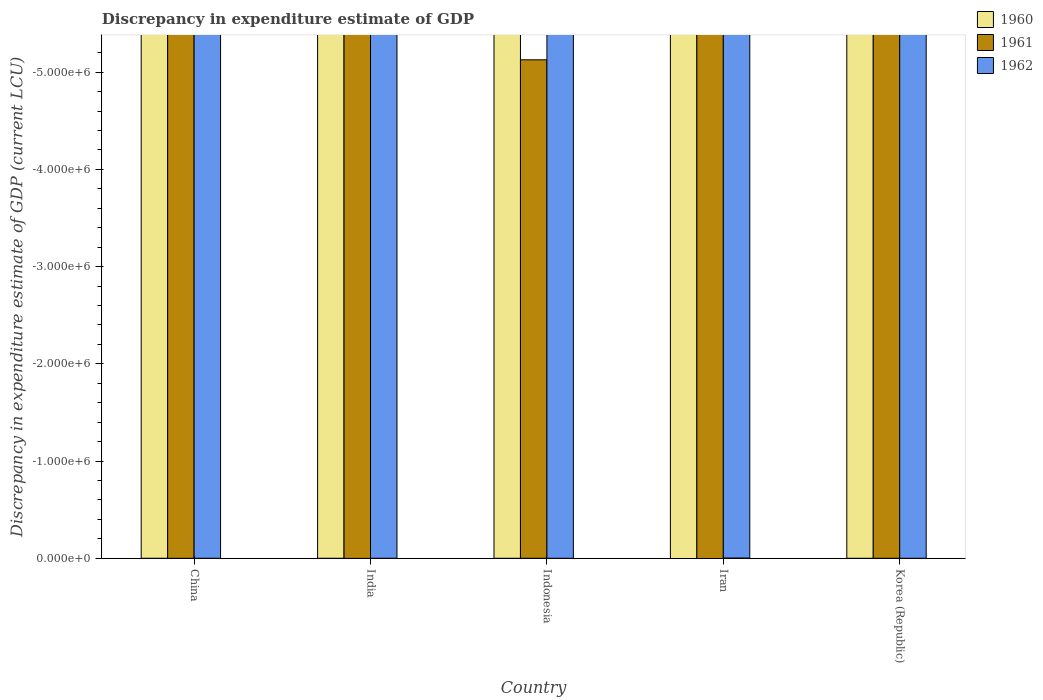How many different coloured bars are there?
Make the answer very short. 0. Are the number of bars per tick equal to the number of legend labels?
Offer a very short reply. No. Are the number of bars on each tick of the X-axis equal?
Your answer should be compact. Yes. How many bars are there on the 1st tick from the left?
Your answer should be compact. 0. What is the label of the 2nd group of bars from the left?
Keep it short and to the point. India. Across all countries, what is the minimum discrepancy in expenditure estimate of GDP in 1960?
Your answer should be compact. 0. What is the total discrepancy in expenditure estimate of GDP in 1962 in the graph?
Ensure brevity in your answer.  0. In how many countries, is the discrepancy in expenditure estimate of GDP in 1962 greater than the average discrepancy in expenditure estimate of GDP in 1962 taken over all countries?
Ensure brevity in your answer.  0. Is it the case that in every country, the sum of the discrepancy in expenditure estimate of GDP in 1962 and discrepancy in expenditure estimate of GDP in 1960 is greater than the discrepancy in expenditure estimate of GDP in 1961?
Keep it short and to the point. No. How many bars are there?
Make the answer very short. 0. Are all the bars in the graph horizontal?
Your answer should be compact. No. Does the graph contain any zero values?
Ensure brevity in your answer.  Yes. Where does the legend appear in the graph?
Your answer should be compact. Top right. What is the title of the graph?
Offer a terse response. Discrepancy in expenditure estimate of GDP. Does "1972" appear as one of the legend labels in the graph?
Your answer should be very brief. No. What is the label or title of the X-axis?
Your answer should be compact. Country. What is the label or title of the Y-axis?
Provide a succinct answer. Discrepancy in expenditure estimate of GDP (current LCU). What is the Discrepancy in expenditure estimate of GDP (current LCU) in 1962 in China?
Ensure brevity in your answer.  0. What is the Discrepancy in expenditure estimate of GDP (current LCU) of 1962 in India?
Offer a terse response. 0. What is the Discrepancy in expenditure estimate of GDP (current LCU) of 1961 in Indonesia?
Provide a short and direct response. 0. What is the Discrepancy in expenditure estimate of GDP (current LCU) of 1962 in Indonesia?
Offer a very short reply. 0. What is the Discrepancy in expenditure estimate of GDP (current LCU) of 1960 in Iran?
Keep it short and to the point. 0. What is the Discrepancy in expenditure estimate of GDP (current LCU) in 1962 in Iran?
Offer a very short reply. 0. What is the Discrepancy in expenditure estimate of GDP (current LCU) of 1961 in Korea (Republic)?
Your response must be concise. 0. What is the average Discrepancy in expenditure estimate of GDP (current LCU) of 1961 per country?
Give a very brief answer. 0. What is the average Discrepancy in expenditure estimate of GDP (current LCU) of 1962 per country?
Your answer should be compact. 0. 